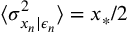Convert formula to latex. <formula><loc_0><loc_0><loc_500><loc_500>\langle \sigma _ { x _ { n } | \epsilon _ { n } } ^ { 2 } \rangle = x _ { * } / 2</formula> 